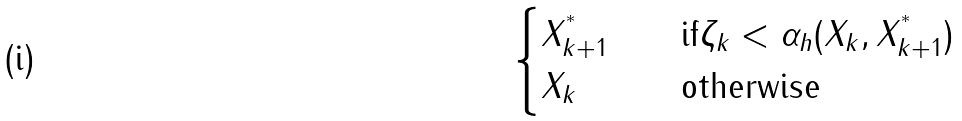Convert formula to latex. <formula><loc_0><loc_0><loc_500><loc_500>\begin{cases} X ^ { ^ { * } } _ { k + 1 } \quad & \text {if} \zeta _ { k } < \alpha _ { h } ( X _ { k } , X ^ { ^ { * } } _ { k + 1 } ) \\ X _ { k } & \text {otherwise} \end{cases}</formula> 